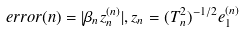Convert formula to latex. <formula><loc_0><loc_0><loc_500><loc_500>e r r o r ( n ) = | \beta _ { n } z _ { n } ^ { ( n ) } | , z _ { n } = ( T _ { n } ^ { 2 } ) ^ { - 1 / 2 } e _ { 1 } ^ { ( n ) }</formula> 